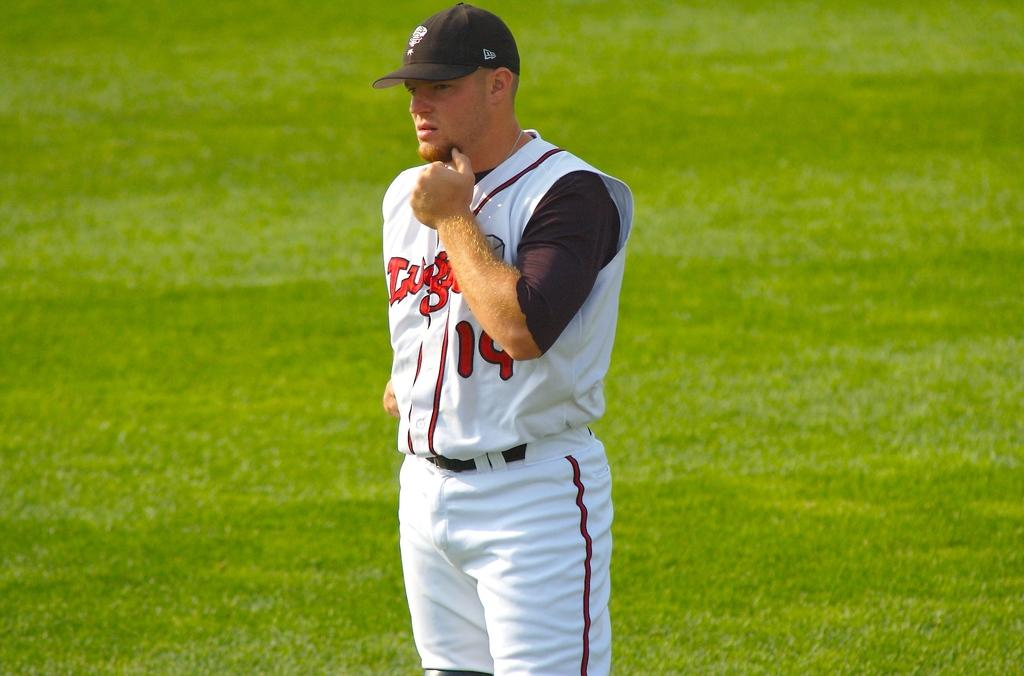<image>
Summarize the visual content of the image. Player number 19 has his hand on his chin in deep thought. 